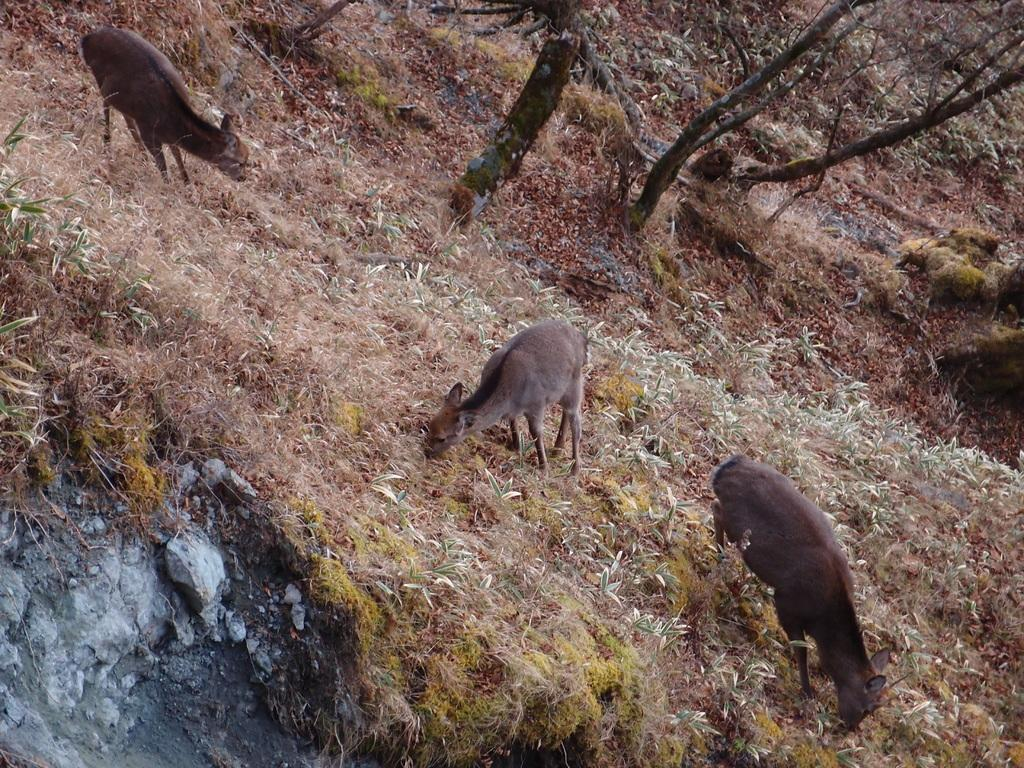What type of animals can be seen on the ground in the image? The image does not specify the type of animals present on the ground. What can be seen in the background of the image? There is grass and trees visible in the background of the image. What plot of land are the animals standing on in the image? The image does not provide information about the specific plot of land where the animals are standing. How many kittens can be seen playing with the animals in the image? There are no kittens present in the image. 